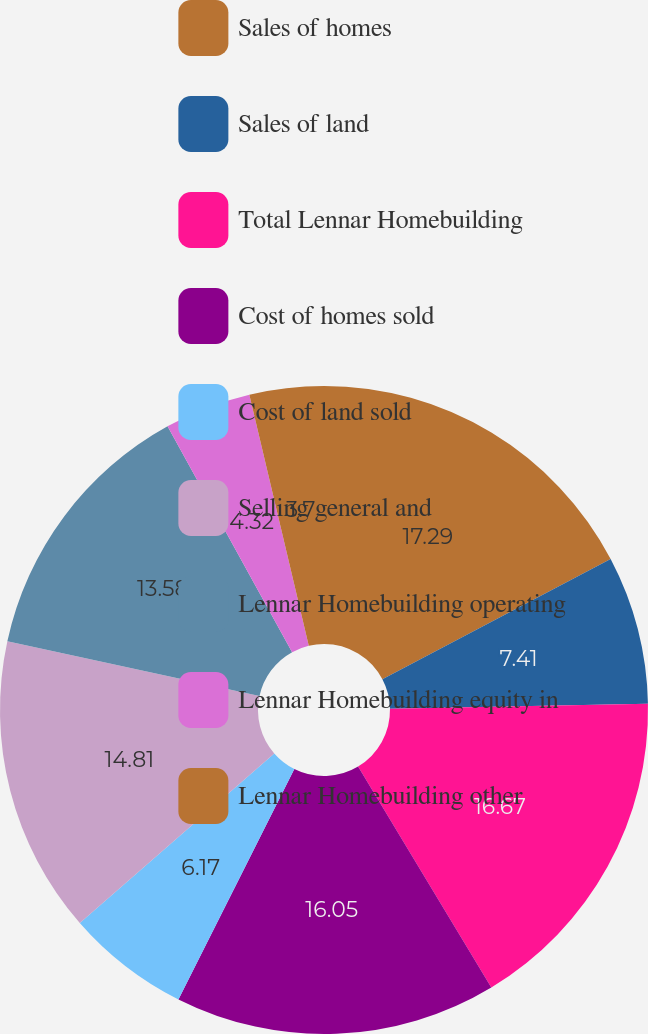Convert chart. <chart><loc_0><loc_0><loc_500><loc_500><pie_chart><fcel>Sales of homes<fcel>Sales of land<fcel>Total Lennar Homebuilding<fcel>Cost of homes sold<fcel>Cost of land sold<fcel>Selling general and<fcel>Lennar Homebuilding operating<fcel>Lennar Homebuilding equity in<fcel>Lennar Homebuilding other<nl><fcel>17.28%<fcel>7.41%<fcel>16.67%<fcel>16.05%<fcel>6.17%<fcel>14.81%<fcel>13.58%<fcel>4.32%<fcel>3.7%<nl></chart> 